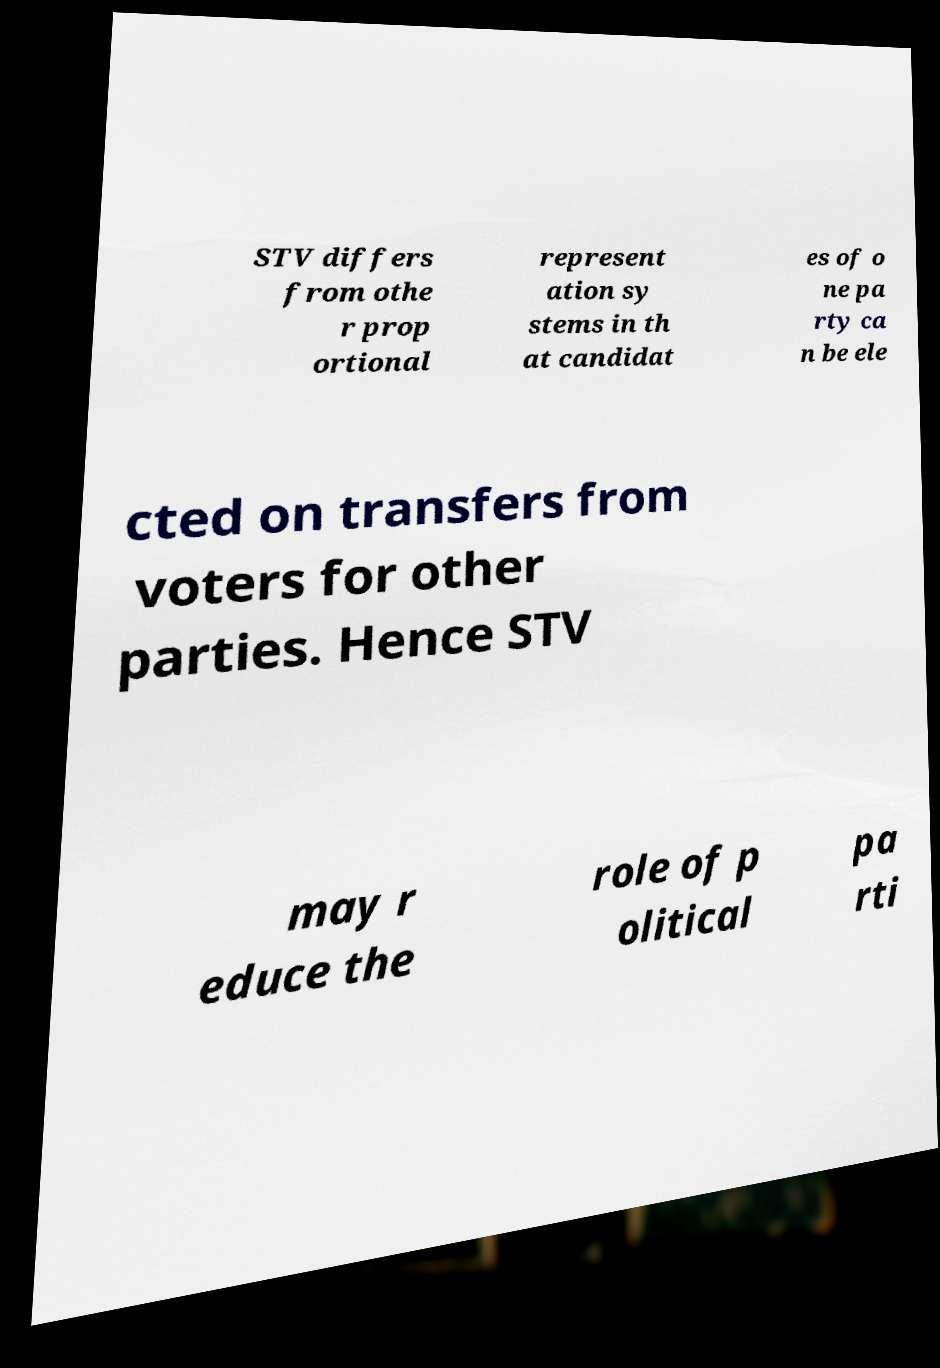Could you extract and type out the text from this image? STV differs from othe r prop ortional represent ation sy stems in th at candidat es of o ne pa rty ca n be ele cted on transfers from voters for other parties. Hence STV may r educe the role of p olitical pa rti 